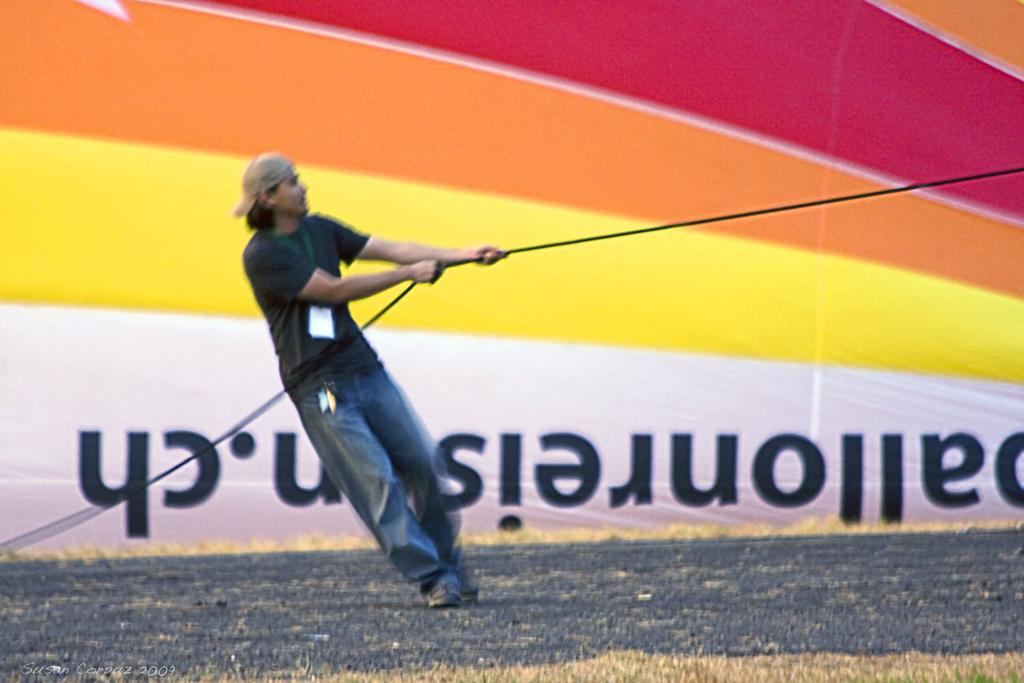What is the main subject of the image? There is a man in the image. What is the man doing in the image? The man is holding a rope with his hands. Can you describe the man's attire? The man is wearing a cap. What can be seen in the background of the image? There is a road and a banner in the background of the image. What type of waves can be seen crashing on the roof in the image? There are no waves or roof present in the image; it features a man holding a rope with a road and banner in the background. 